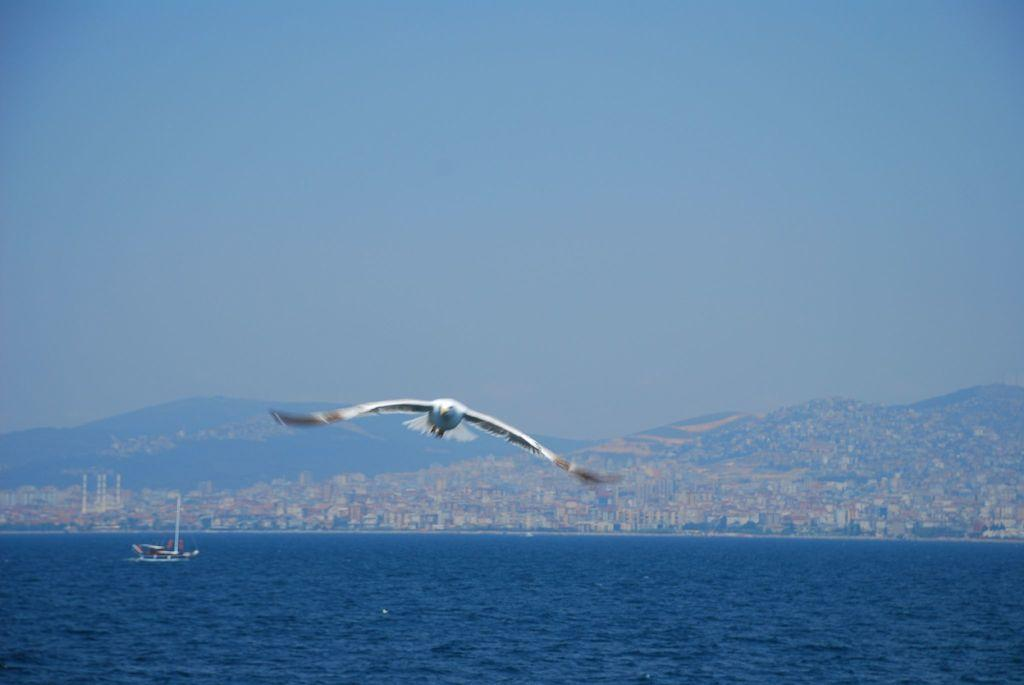What animal is flying in the image? There is an eagle flying in the image. Where is the eagle located in relation to the sea? The eagle is above the sea. What can be seen sailing on the sea? There is a ship sailing on the sea. What is visible in the background of the image? There is a big city and mountains visible in the background. What type of wood is the eagle using to build its nest in the image? There is no nest visible in the image, and the eagle is flying, not building a nest. 